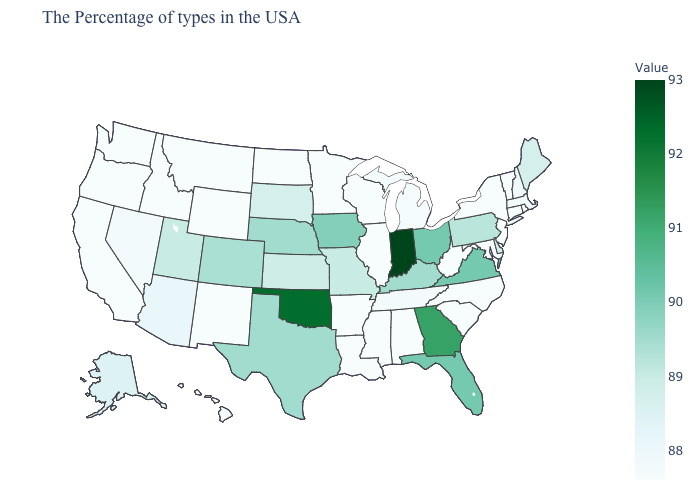Which states have the lowest value in the USA?
Short answer required. Rhode Island, Vermont, Connecticut, New York, New Jersey, Maryland, North Carolina, South Carolina, West Virginia, Alabama, Wisconsin, Illinois, Mississippi, Louisiana, Arkansas, Minnesota, North Dakota, Wyoming, New Mexico, Montana, Idaho, California, Washington, Oregon, Hawaii. Which states hav the highest value in the MidWest?
Quick response, please. Indiana. Among the states that border Delaware , which have the highest value?
Be succinct. Pennsylvania. Which states have the highest value in the USA?
Short answer required. Indiana. Among the states that border Arizona , does New Mexico have the highest value?
Keep it brief. No. Which states hav the highest value in the West?
Be succinct. Colorado. Among the states that border Nebraska , which have the highest value?
Concise answer only. Iowa. Among the states that border New Hampshire , does Massachusetts have the highest value?
Write a very short answer. No. 